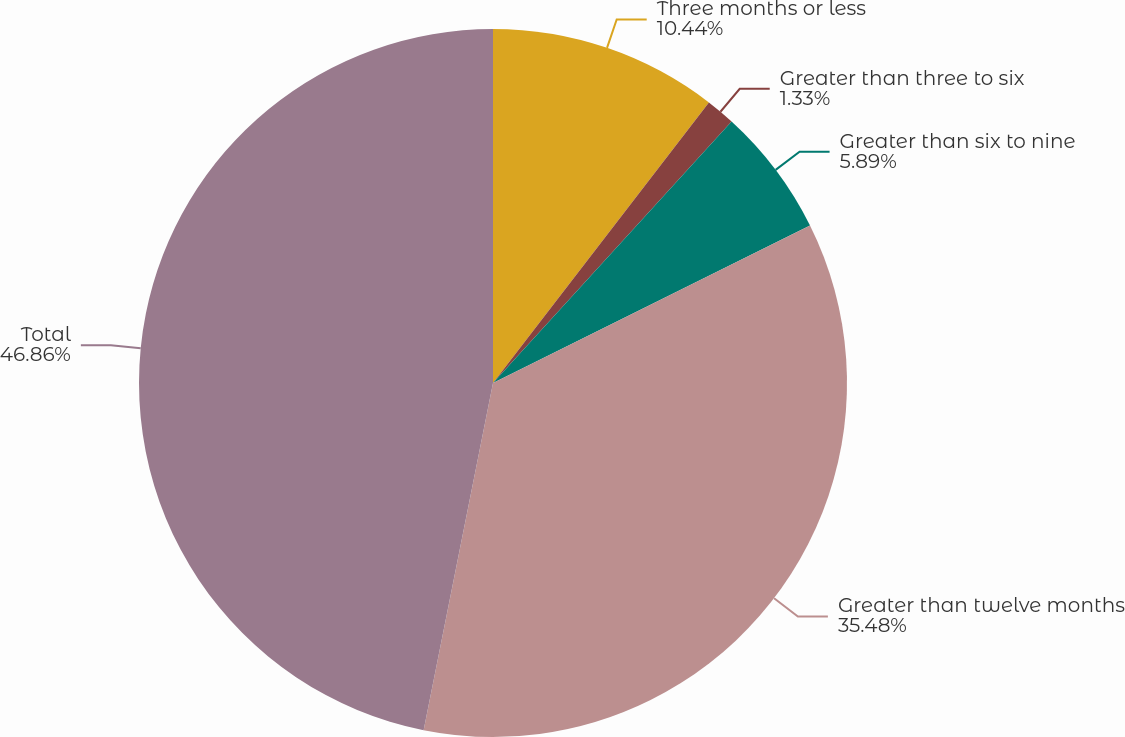Convert chart. <chart><loc_0><loc_0><loc_500><loc_500><pie_chart><fcel>Three months or less<fcel>Greater than three to six<fcel>Greater than six to nine<fcel>Greater than twelve months<fcel>Total<nl><fcel>10.44%<fcel>1.33%<fcel>5.89%<fcel>35.48%<fcel>46.86%<nl></chart> 